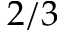<formula> <loc_0><loc_0><loc_500><loc_500>2 / 3</formula> 